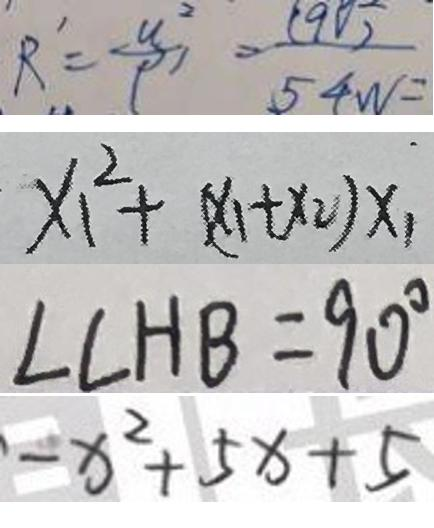Convert formula to latex. <formula><loc_0><loc_0><loc_500><loc_500>R ^ { \prime } = \frac { u ^ { 2 } } { \rho ^ { \prime } } = \frac { 1 9 0 } { 5 4 w } = 
 x _ { 1 } ^ { 2 } + ( x _ { 1 } + x _ { 2 } ) x _ { 1 } 
 \angle C H B = 9 0 ^ { \circ } 
 - x ^ { 2 } + 5 x + 5</formula> 